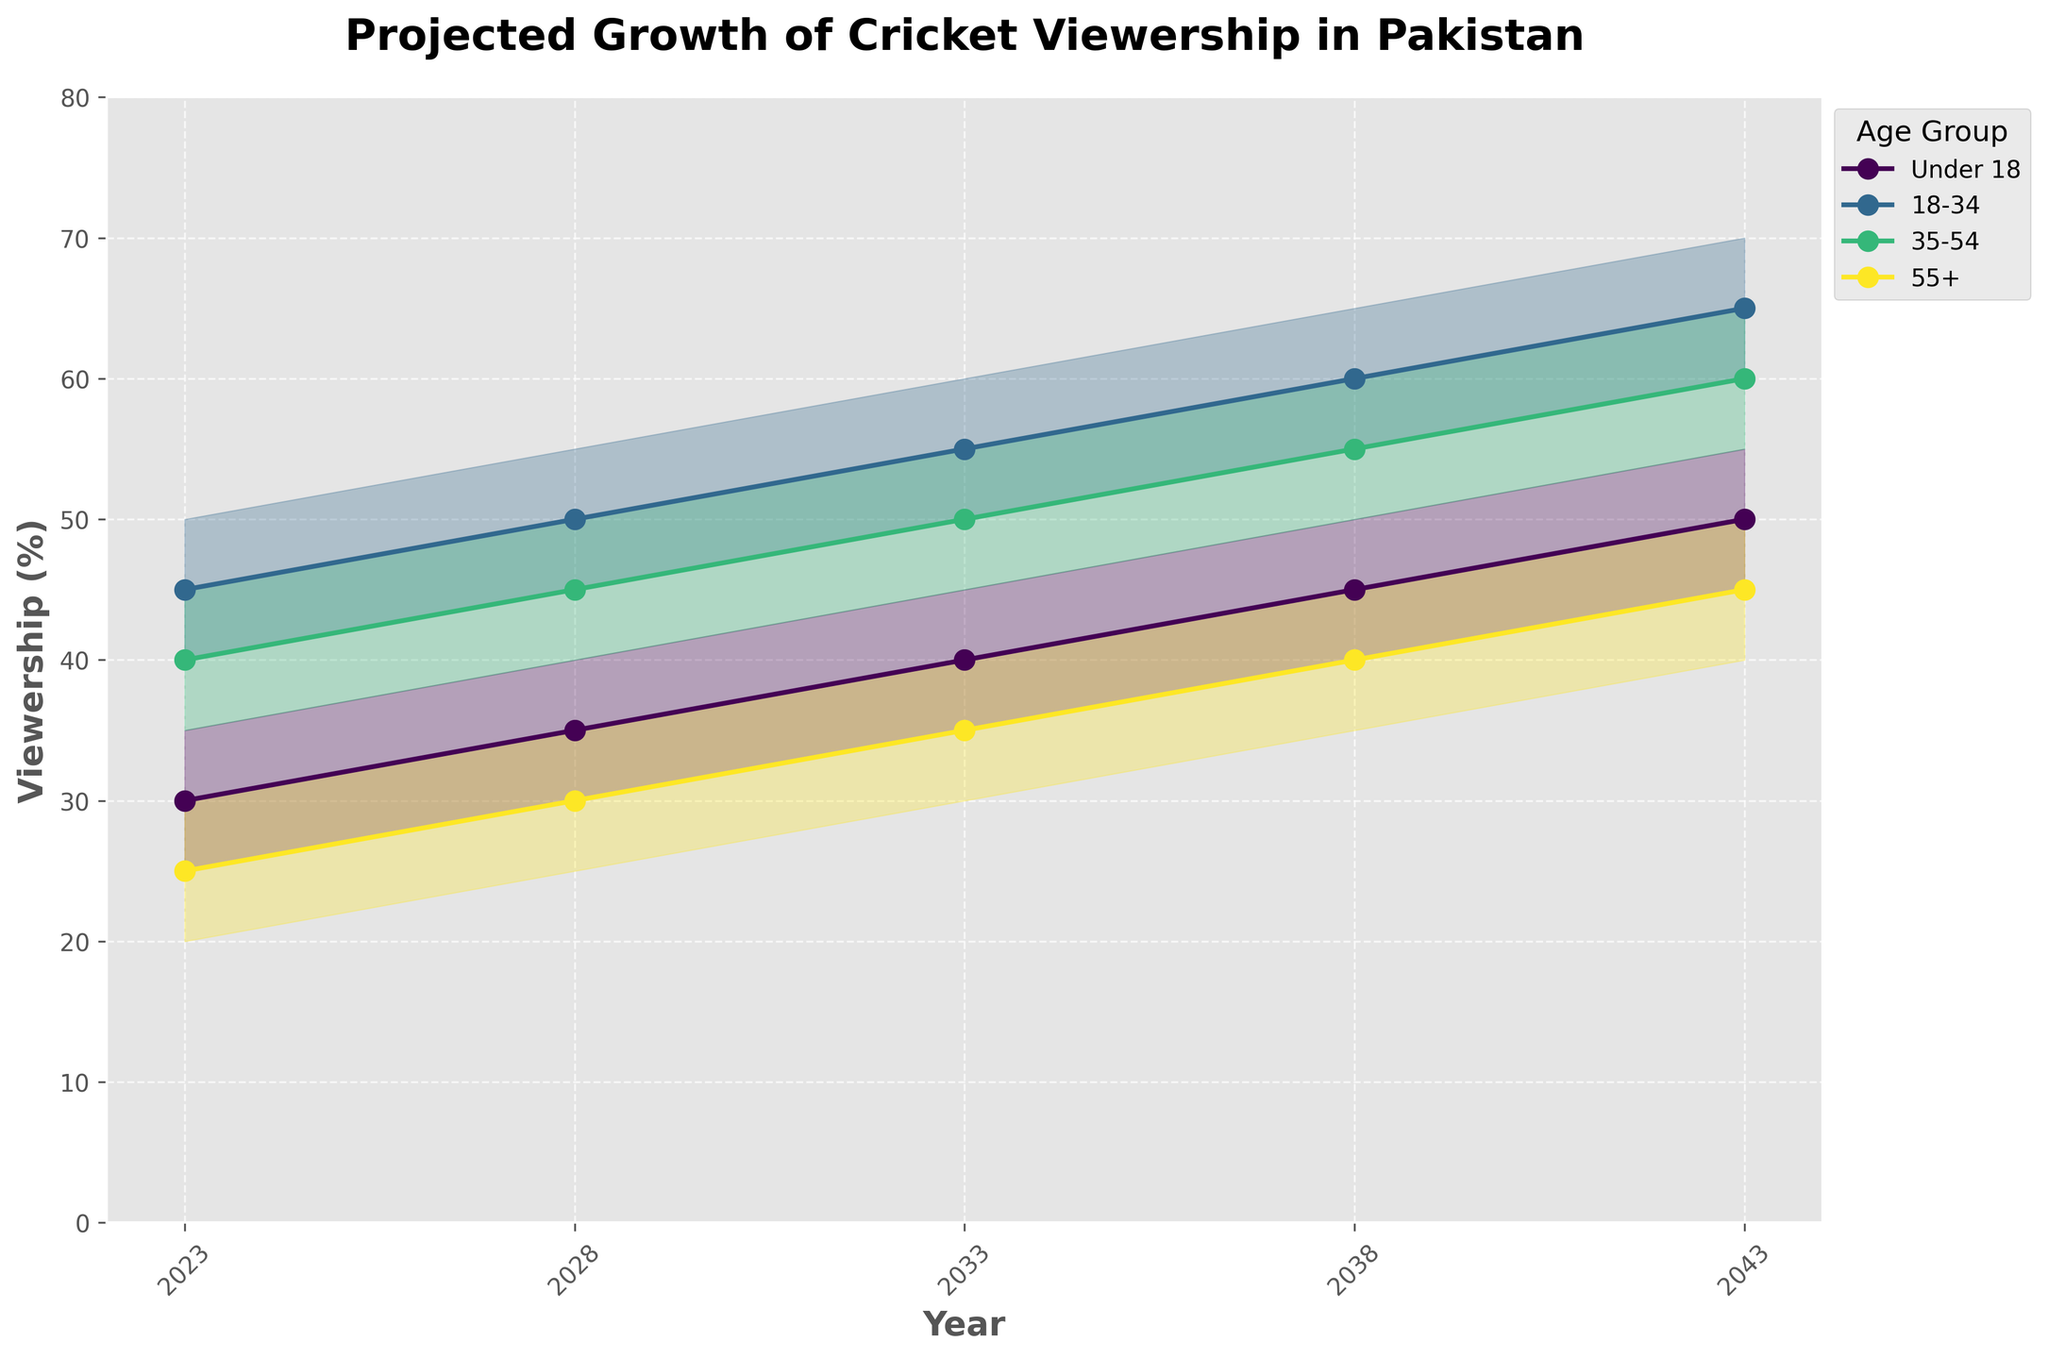What's the projected viewership percentage for the 18-34 age group in 2043 according to the medium estimate? The medium estimate data plot shows the viewership for the 18-34 age group in 2043. According to the plot, the medium estimate for this age group is 65%.
Answer: 65% Which age group is projected to experience the highest viewership percentage in 2043 according to the high estimate? To find the highest projected viewership percentage by 2043, look at the high estimates for all age groups in 2043. The 18-34 age group has the highest estimate at 70%.
Answer: 18-34 By how much is the under 18 viewership expected to increase from 2023 to 2043 according to the medium estimate? The medium estimate for under 18 in 2023 is 30%, and in 2043 it is 50%. The increase is calculated as 50% - 30% = 20%.
Answer: 20% In which year does the 55+ age group cross a medium estimate of 35% viewership? By examining the medium estimates for the 55+ age group over the years, we see that they cross 35% viewership in the year 2033.
Answer: 2033 Which age group's viewership is estimated to grow the most between 2023 and 2028 according to the medium estimate? The medium estimates of each age group are as follows: 
- Under 18: from 30% to 35% (increase of 5%)
- 18-34: from 45% to 50% (increase of 5%)
- 35-54: from 40% to 45% (increase of 5%)
- 55+: from 25% to 30% (increase of 5%)
All age groups are projected to grow by the same amount of 5%.
Answer: All age groups Over the 20 years, which age group shows the least variation in viewership percentages according to the range between the low and high estimates? To determine the least variation, calculate the difference between the high and low estimates for each age group across all years. The 55+ age group shows a consistent range of 10% between the low and high estimates.
Answer: 55+ What is the potential range of viewership for the 35-54 age group in 2038? According to the plot, the low estimate for 2038 in the 35-54 age group is 50%, and the high estimate is 60%. Thus, the range is 50% to 60%.
Answer: 50% to 60% Between which years does the under 18 age group's medium viewership estimate surpass the 55+ age group's medium estimate? Track the medium viewership estimates for both age groups. The under 18 age group's medium estimate surpasses the 55+ group’s medium estimate between 2023 and 2028.
Answer: Between 2023 and 2028 